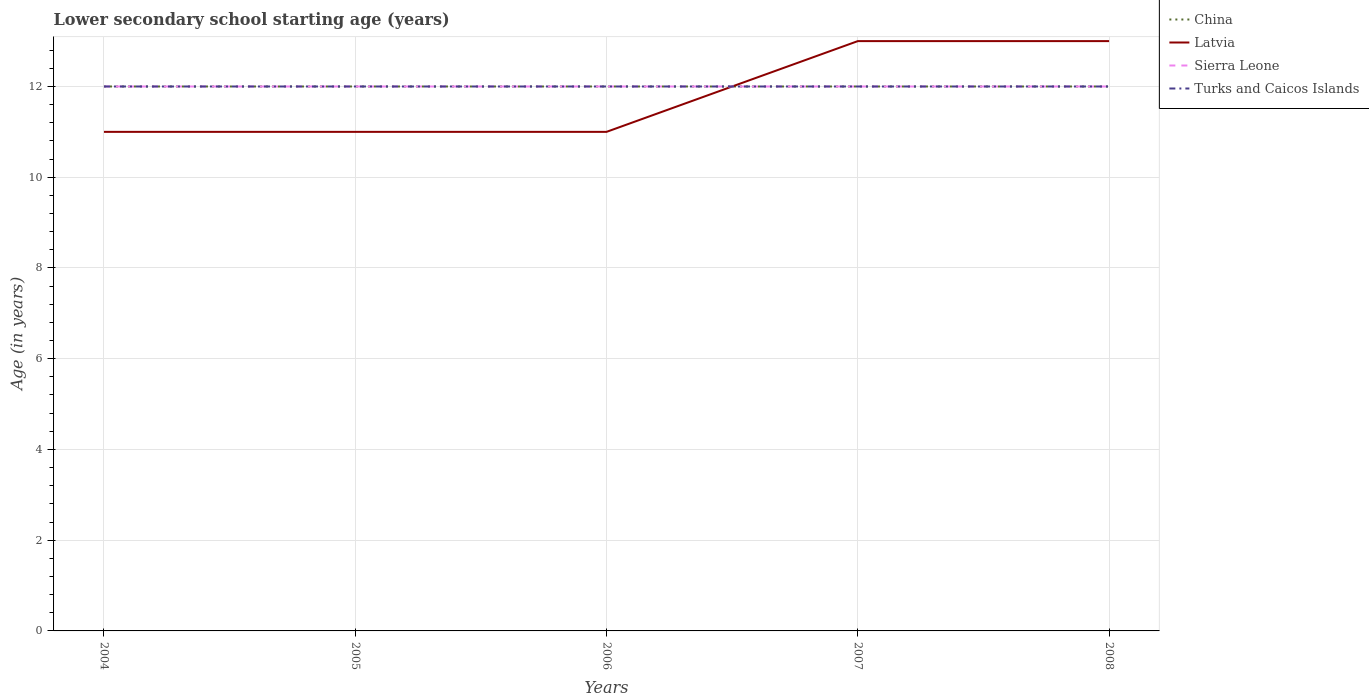How many different coloured lines are there?
Provide a short and direct response. 4. Does the line corresponding to China intersect with the line corresponding to Latvia?
Offer a terse response. Yes. Is the number of lines equal to the number of legend labels?
Your answer should be compact. Yes. Across all years, what is the maximum lower secondary school starting age of children in China?
Your response must be concise. 12. What is the total lower secondary school starting age of children in Latvia in the graph?
Your answer should be compact. -2. What is the difference between the highest and the second highest lower secondary school starting age of children in Turks and Caicos Islands?
Your response must be concise. 0. What is the difference between the highest and the lowest lower secondary school starting age of children in Turks and Caicos Islands?
Your answer should be compact. 0. Is the lower secondary school starting age of children in Sierra Leone strictly greater than the lower secondary school starting age of children in Turks and Caicos Islands over the years?
Ensure brevity in your answer.  No. How many lines are there?
Make the answer very short. 4. How many legend labels are there?
Give a very brief answer. 4. How are the legend labels stacked?
Make the answer very short. Vertical. What is the title of the graph?
Your answer should be very brief. Lower secondary school starting age (years). Does "Equatorial Guinea" appear as one of the legend labels in the graph?
Make the answer very short. No. What is the label or title of the Y-axis?
Offer a very short reply. Age (in years). What is the Age (in years) of China in 2004?
Your answer should be compact. 12. What is the Age (in years) in Latvia in 2004?
Provide a short and direct response. 11. What is the Age (in years) in Latvia in 2005?
Give a very brief answer. 11. What is the Age (in years) of China in 2006?
Your response must be concise. 12. What is the Age (in years) of Turks and Caicos Islands in 2006?
Ensure brevity in your answer.  12. What is the Age (in years) of China in 2007?
Give a very brief answer. 12. What is the Age (in years) of Latvia in 2007?
Your answer should be compact. 13. What is the Age (in years) of China in 2008?
Ensure brevity in your answer.  12. What is the Age (in years) in Latvia in 2008?
Your answer should be compact. 13. What is the Age (in years) in Sierra Leone in 2008?
Your response must be concise. 12. What is the Age (in years) in Turks and Caicos Islands in 2008?
Ensure brevity in your answer.  12. Across all years, what is the maximum Age (in years) in Sierra Leone?
Your answer should be compact. 12. Across all years, what is the minimum Age (in years) of Sierra Leone?
Offer a very short reply. 12. What is the total Age (in years) in China in the graph?
Offer a terse response. 60. What is the total Age (in years) in Latvia in the graph?
Make the answer very short. 59. What is the total Age (in years) of Sierra Leone in the graph?
Your answer should be very brief. 60. What is the difference between the Age (in years) in Turks and Caicos Islands in 2004 and that in 2005?
Provide a succinct answer. 0. What is the difference between the Age (in years) in China in 2004 and that in 2006?
Keep it short and to the point. 0. What is the difference between the Age (in years) of Sierra Leone in 2004 and that in 2006?
Make the answer very short. 0. What is the difference between the Age (in years) in Turks and Caicos Islands in 2004 and that in 2006?
Offer a very short reply. 0. What is the difference between the Age (in years) of Latvia in 2004 and that in 2007?
Give a very brief answer. -2. What is the difference between the Age (in years) in Sierra Leone in 2004 and that in 2007?
Provide a short and direct response. 0. What is the difference between the Age (in years) in Turks and Caicos Islands in 2004 and that in 2007?
Your answer should be very brief. 0. What is the difference between the Age (in years) of China in 2004 and that in 2008?
Provide a succinct answer. 0. What is the difference between the Age (in years) in Latvia in 2004 and that in 2008?
Your answer should be compact. -2. What is the difference between the Age (in years) in Sierra Leone in 2004 and that in 2008?
Make the answer very short. 0. What is the difference between the Age (in years) in Latvia in 2005 and that in 2006?
Ensure brevity in your answer.  0. What is the difference between the Age (in years) in Sierra Leone in 2005 and that in 2006?
Give a very brief answer. 0. What is the difference between the Age (in years) of Turks and Caicos Islands in 2005 and that in 2006?
Offer a very short reply. 0. What is the difference between the Age (in years) of China in 2005 and that in 2007?
Offer a terse response. 0. What is the difference between the Age (in years) in Latvia in 2005 and that in 2007?
Give a very brief answer. -2. What is the difference between the Age (in years) in Sierra Leone in 2005 and that in 2007?
Provide a succinct answer. 0. What is the difference between the Age (in years) in China in 2005 and that in 2008?
Your response must be concise. 0. What is the difference between the Age (in years) in Latvia in 2005 and that in 2008?
Make the answer very short. -2. What is the difference between the Age (in years) of Latvia in 2006 and that in 2007?
Your response must be concise. -2. What is the difference between the Age (in years) of China in 2006 and that in 2008?
Your answer should be compact. 0. What is the difference between the Age (in years) in China in 2007 and that in 2008?
Provide a succinct answer. 0. What is the difference between the Age (in years) in Latvia in 2007 and that in 2008?
Keep it short and to the point. 0. What is the difference between the Age (in years) in China in 2004 and the Age (in years) in Latvia in 2005?
Provide a succinct answer. 1. What is the difference between the Age (in years) of China in 2004 and the Age (in years) of Sierra Leone in 2005?
Offer a very short reply. 0. What is the difference between the Age (in years) of Latvia in 2004 and the Age (in years) of Turks and Caicos Islands in 2005?
Your response must be concise. -1. What is the difference between the Age (in years) in Sierra Leone in 2004 and the Age (in years) in Turks and Caicos Islands in 2005?
Your response must be concise. 0. What is the difference between the Age (in years) in China in 2004 and the Age (in years) in Latvia in 2006?
Provide a short and direct response. 1. What is the difference between the Age (in years) in China in 2004 and the Age (in years) in Sierra Leone in 2006?
Provide a succinct answer. 0. What is the difference between the Age (in years) in China in 2004 and the Age (in years) in Turks and Caicos Islands in 2006?
Your response must be concise. 0. What is the difference between the Age (in years) of China in 2004 and the Age (in years) of Latvia in 2008?
Provide a succinct answer. -1. What is the difference between the Age (in years) of China in 2004 and the Age (in years) of Sierra Leone in 2008?
Keep it short and to the point. 0. What is the difference between the Age (in years) in Sierra Leone in 2004 and the Age (in years) in Turks and Caicos Islands in 2008?
Ensure brevity in your answer.  0. What is the difference between the Age (in years) of Latvia in 2005 and the Age (in years) of Sierra Leone in 2006?
Your answer should be compact. -1. What is the difference between the Age (in years) of China in 2005 and the Age (in years) of Sierra Leone in 2007?
Provide a succinct answer. 0. What is the difference between the Age (in years) of China in 2005 and the Age (in years) of Turks and Caicos Islands in 2007?
Your answer should be very brief. 0. What is the difference between the Age (in years) in Latvia in 2005 and the Age (in years) in Sierra Leone in 2008?
Offer a very short reply. -1. What is the difference between the Age (in years) of Latvia in 2005 and the Age (in years) of Turks and Caicos Islands in 2008?
Offer a very short reply. -1. What is the difference between the Age (in years) in Sierra Leone in 2005 and the Age (in years) in Turks and Caicos Islands in 2008?
Your answer should be compact. 0. What is the difference between the Age (in years) of China in 2006 and the Age (in years) of Sierra Leone in 2007?
Make the answer very short. 0. What is the difference between the Age (in years) of Latvia in 2006 and the Age (in years) of Sierra Leone in 2007?
Offer a terse response. -1. What is the difference between the Age (in years) of Latvia in 2006 and the Age (in years) of Turks and Caicos Islands in 2007?
Offer a very short reply. -1. What is the difference between the Age (in years) of Sierra Leone in 2006 and the Age (in years) of Turks and Caicos Islands in 2007?
Keep it short and to the point. 0. What is the difference between the Age (in years) of China in 2006 and the Age (in years) of Latvia in 2008?
Keep it short and to the point. -1. What is the difference between the Age (in years) in China in 2006 and the Age (in years) in Sierra Leone in 2008?
Offer a terse response. 0. What is the difference between the Age (in years) of China in 2006 and the Age (in years) of Turks and Caicos Islands in 2008?
Provide a succinct answer. 0. What is the difference between the Age (in years) of Latvia in 2006 and the Age (in years) of Turks and Caicos Islands in 2008?
Keep it short and to the point. -1. What is the difference between the Age (in years) of China in 2007 and the Age (in years) of Sierra Leone in 2008?
Give a very brief answer. 0. What is the difference between the Age (in years) of China in 2007 and the Age (in years) of Turks and Caicos Islands in 2008?
Your answer should be compact. 0. What is the difference between the Age (in years) in Latvia in 2007 and the Age (in years) in Sierra Leone in 2008?
Provide a short and direct response. 1. What is the difference between the Age (in years) of Latvia in 2007 and the Age (in years) of Turks and Caicos Islands in 2008?
Give a very brief answer. 1. In the year 2004, what is the difference between the Age (in years) of China and Age (in years) of Sierra Leone?
Offer a terse response. 0. In the year 2004, what is the difference between the Age (in years) of China and Age (in years) of Turks and Caicos Islands?
Keep it short and to the point. 0. In the year 2004, what is the difference between the Age (in years) in Latvia and Age (in years) in Sierra Leone?
Give a very brief answer. -1. In the year 2004, what is the difference between the Age (in years) in Latvia and Age (in years) in Turks and Caicos Islands?
Provide a succinct answer. -1. In the year 2005, what is the difference between the Age (in years) in China and Age (in years) in Sierra Leone?
Your answer should be compact. 0. In the year 2005, what is the difference between the Age (in years) of China and Age (in years) of Turks and Caicos Islands?
Give a very brief answer. 0. In the year 2005, what is the difference between the Age (in years) of Latvia and Age (in years) of Sierra Leone?
Ensure brevity in your answer.  -1. In the year 2005, what is the difference between the Age (in years) of Latvia and Age (in years) of Turks and Caicos Islands?
Offer a terse response. -1. In the year 2005, what is the difference between the Age (in years) of Sierra Leone and Age (in years) of Turks and Caicos Islands?
Make the answer very short. 0. In the year 2006, what is the difference between the Age (in years) in China and Age (in years) in Latvia?
Give a very brief answer. 1. In the year 2006, what is the difference between the Age (in years) in Latvia and Age (in years) in Sierra Leone?
Offer a terse response. -1. In the year 2007, what is the difference between the Age (in years) in China and Age (in years) in Latvia?
Keep it short and to the point. -1. In the year 2007, what is the difference between the Age (in years) of China and Age (in years) of Turks and Caicos Islands?
Offer a terse response. 0. In the year 2007, what is the difference between the Age (in years) in Latvia and Age (in years) in Turks and Caicos Islands?
Your answer should be very brief. 1. In the year 2007, what is the difference between the Age (in years) in Sierra Leone and Age (in years) in Turks and Caicos Islands?
Ensure brevity in your answer.  0. In the year 2008, what is the difference between the Age (in years) in China and Age (in years) in Turks and Caicos Islands?
Provide a short and direct response. 0. In the year 2008, what is the difference between the Age (in years) in Latvia and Age (in years) in Turks and Caicos Islands?
Your response must be concise. 1. What is the ratio of the Age (in years) in China in 2004 to that in 2005?
Your answer should be compact. 1. What is the ratio of the Age (in years) of Sierra Leone in 2004 to that in 2005?
Give a very brief answer. 1. What is the ratio of the Age (in years) in Latvia in 2004 to that in 2006?
Keep it short and to the point. 1. What is the ratio of the Age (in years) in Turks and Caicos Islands in 2004 to that in 2006?
Make the answer very short. 1. What is the ratio of the Age (in years) of China in 2004 to that in 2007?
Ensure brevity in your answer.  1. What is the ratio of the Age (in years) of Latvia in 2004 to that in 2007?
Offer a very short reply. 0.85. What is the ratio of the Age (in years) in Sierra Leone in 2004 to that in 2007?
Provide a succinct answer. 1. What is the ratio of the Age (in years) of Turks and Caicos Islands in 2004 to that in 2007?
Provide a short and direct response. 1. What is the ratio of the Age (in years) of China in 2004 to that in 2008?
Provide a succinct answer. 1. What is the ratio of the Age (in years) of Latvia in 2004 to that in 2008?
Offer a very short reply. 0.85. What is the ratio of the Age (in years) of China in 2005 to that in 2006?
Give a very brief answer. 1. What is the ratio of the Age (in years) in Turks and Caicos Islands in 2005 to that in 2006?
Your answer should be very brief. 1. What is the ratio of the Age (in years) of Latvia in 2005 to that in 2007?
Offer a very short reply. 0.85. What is the ratio of the Age (in years) of China in 2005 to that in 2008?
Keep it short and to the point. 1. What is the ratio of the Age (in years) in Latvia in 2005 to that in 2008?
Keep it short and to the point. 0.85. What is the ratio of the Age (in years) of Turks and Caicos Islands in 2005 to that in 2008?
Ensure brevity in your answer.  1. What is the ratio of the Age (in years) in China in 2006 to that in 2007?
Ensure brevity in your answer.  1. What is the ratio of the Age (in years) in Latvia in 2006 to that in 2007?
Give a very brief answer. 0.85. What is the ratio of the Age (in years) in China in 2006 to that in 2008?
Your answer should be compact. 1. What is the ratio of the Age (in years) of Latvia in 2006 to that in 2008?
Keep it short and to the point. 0.85. What is the ratio of the Age (in years) in Sierra Leone in 2006 to that in 2008?
Your answer should be very brief. 1. What is the ratio of the Age (in years) in Turks and Caicos Islands in 2006 to that in 2008?
Keep it short and to the point. 1. What is the difference between the highest and the second highest Age (in years) of China?
Your response must be concise. 0. What is the difference between the highest and the second highest Age (in years) of Turks and Caicos Islands?
Offer a terse response. 0. What is the difference between the highest and the lowest Age (in years) of China?
Ensure brevity in your answer.  0. 